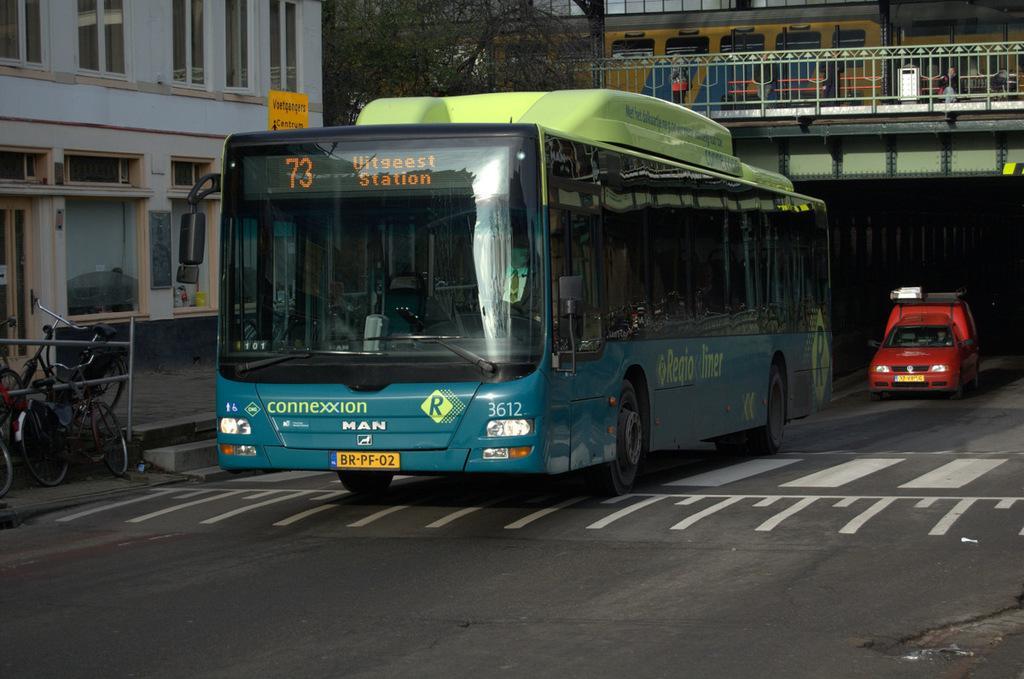Please provide a concise description of this image. In this image, we can see vehicles on the road and in the background, there are bicycles and we can see a building and a tree. At the top, we can see a foot over bridge and there is a train. 